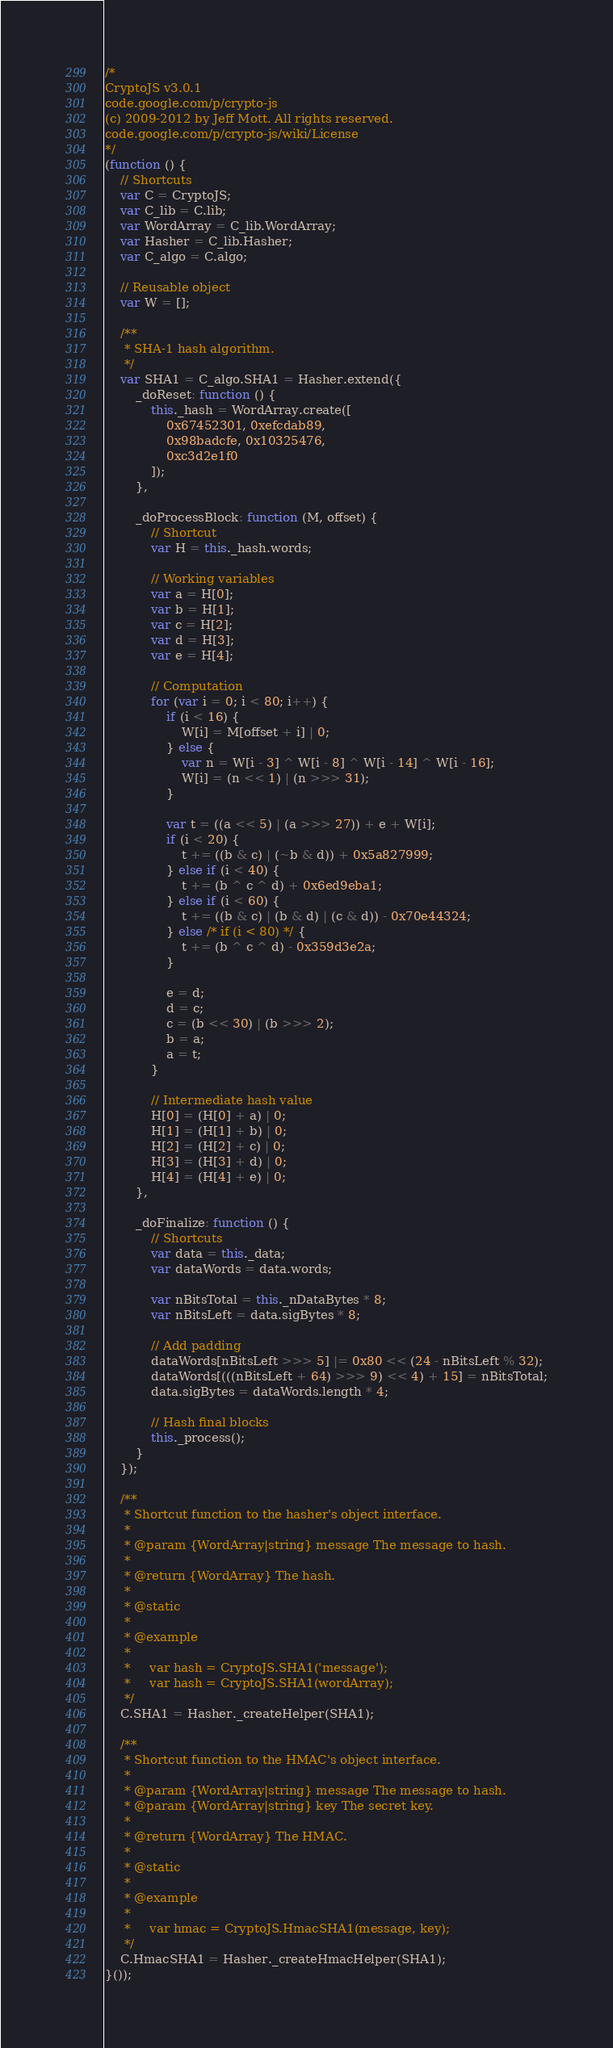<code> <loc_0><loc_0><loc_500><loc_500><_JavaScript_>/*
CryptoJS v3.0.1
code.google.com/p/crypto-js
(c) 2009-2012 by Jeff Mott. All rights reserved.
code.google.com/p/crypto-js/wiki/License
*/
(function () {
    // Shortcuts
    var C = CryptoJS;
    var C_lib = C.lib;
    var WordArray = C_lib.WordArray;
    var Hasher = C_lib.Hasher;
    var C_algo = C.algo;

    // Reusable object
    var W = [];

    /**
     * SHA-1 hash algorithm.
     */
    var SHA1 = C_algo.SHA1 = Hasher.extend({
        _doReset: function () {
            this._hash = WordArray.create([
                0x67452301, 0xefcdab89,
                0x98badcfe, 0x10325476,
                0xc3d2e1f0
            ]);
        },

        _doProcessBlock: function (M, offset) {
            // Shortcut
            var H = this._hash.words;

            // Working variables
            var a = H[0];
            var b = H[1];
            var c = H[2];
            var d = H[3];
            var e = H[4];

            // Computation
            for (var i = 0; i < 80; i++) {
                if (i < 16) {
                    W[i] = M[offset + i] | 0;
                } else {
                    var n = W[i - 3] ^ W[i - 8] ^ W[i - 14] ^ W[i - 16];
                    W[i] = (n << 1) | (n >>> 31);
                }

                var t = ((a << 5) | (a >>> 27)) + e + W[i];
                if (i < 20) {
                    t += ((b & c) | (~b & d)) + 0x5a827999;
                } else if (i < 40) {
                    t += (b ^ c ^ d) + 0x6ed9eba1;
                } else if (i < 60) {
                    t += ((b & c) | (b & d) | (c & d)) - 0x70e44324;
                } else /* if (i < 80) */ {
                    t += (b ^ c ^ d) - 0x359d3e2a;
                }

                e = d;
                d = c;
                c = (b << 30) | (b >>> 2);
                b = a;
                a = t;
            }

            // Intermediate hash value
            H[0] = (H[0] + a) | 0;
            H[1] = (H[1] + b) | 0;
            H[2] = (H[2] + c) | 0;
            H[3] = (H[3] + d) | 0;
            H[4] = (H[4] + e) | 0;
        },

        _doFinalize: function () {
            // Shortcuts
            var data = this._data;
            var dataWords = data.words;

            var nBitsTotal = this._nDataBytes * 8;
            var nBitsLeft = data.sigBytes * 8;

            // Add padding
            dataWords[nBitsLeft >>> 5] |= 0x80 << (24 - nBitsLeft % 32);
            dataWords[(((nBitsLeft + 64) >>> 9) << 4) + 15] = nBitsTotal;
            data.sigBytes = dataWords.length * 4;

            // Hash final blocks
            this._process();
        }
    });

    /**
     * Shortcut function to the hasher's object interface.
     *
     * @param {WordArray|string} message The message to hash.
     *
     * @return {WordArray} The hash.
     *
     * @static
     *
     * @example
     *
     *     var hash = CryptoJS.SHA1('message');
     *     var hash = CryptoJS.SHA1(wordArray);
     */
    C.SHA1 = Hasher._createHelper(SHA1);

    /**
     * Shortcut function to the HMAC's object interface.
     *
     * @param {WordArray|string} message The message to hash.
     * @param {WordArray|string} key The secret key.
     *
     * @return {WordArray} The HMAC.
     *
     * @static
     *
     * @example
     *
     *     var hmac = CryptoJS.HmacSHA1(message, key);
     */
    C.HmacSHA1 = Hasher._createHmacHelper(SHA1);
}());
</code> 